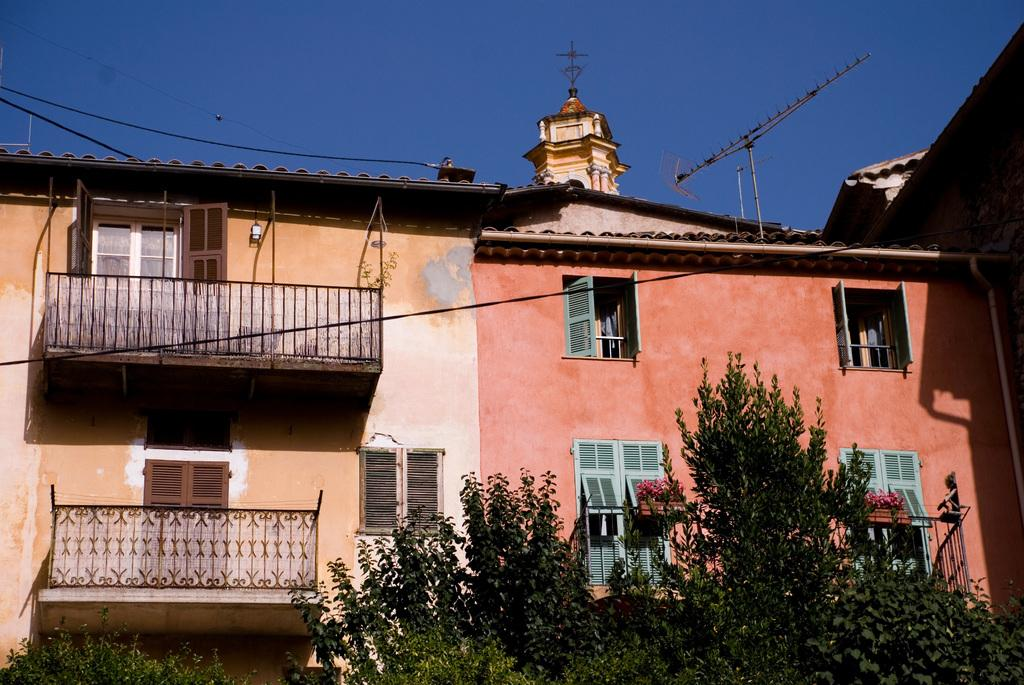What type of natural elements can be seen in the image? There are trees in the image. What type of man-made structure is present in the image? There is a building in the image. What architectural features can be seen in the image? There are windows, poles, wires, and a railing in the image. What is visible in the background of the image? The sky is visible in the background of the image. What is the color of the sky in the image? The color of the sky is blue. How many houses are visible in the image? There are no houses visible in the image; it features a building, trees, and various architectural elements. What type of fact can be observed about the sky in the image? There is no specific fact about the sky in the image, other than its blue color. 